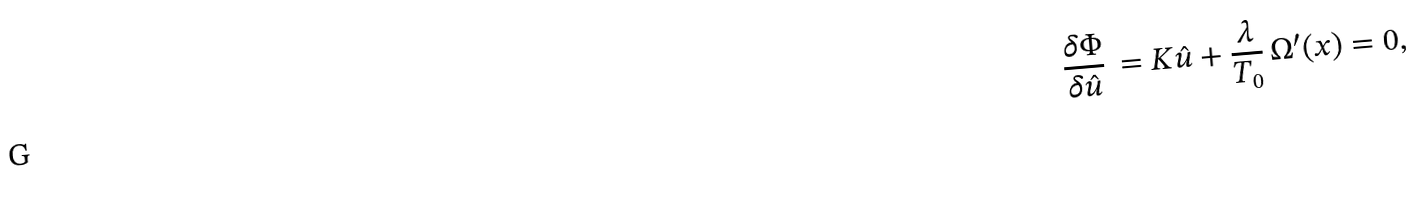<formula> <loc_0><loc_0><loc_500><loc_500>\frac { \delta \Phi } { \delta \hat { u } } \, = K \hat { u } + \frac { \lambda } { T _ { 0 } } \, \Omega ^ { \prime } ( x ) = 0 ,</formula> 